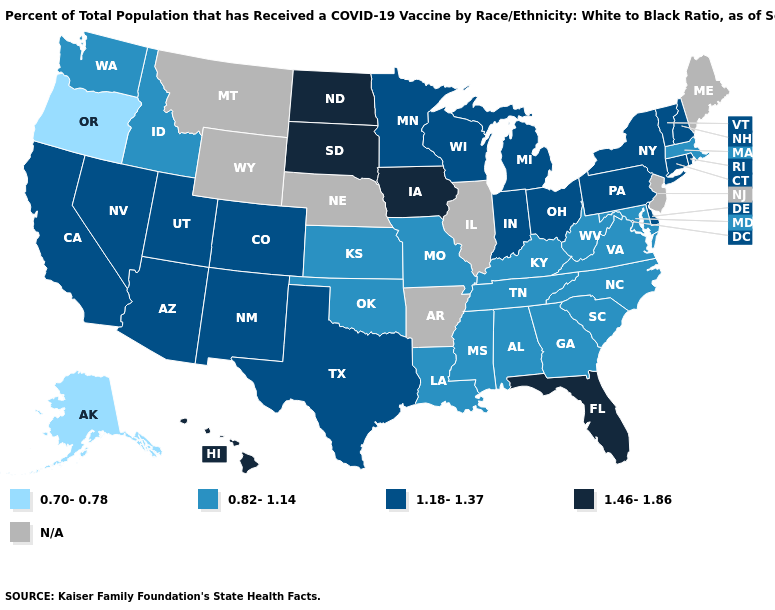What is the highest value in the Northeast ?
Answer briefly. 1.18-1.37. Does the first symbol in the legend represent the smallest category?
Short answer required. Yes. Is the legend a continuous bar?
Keep it brief. No. What is the lowest value in states that border North Dakota?
Give a very brief answer. 1.18-1.37. Does the first symbol in the legend represent the smallest category?
Write a very short answer. Yes. Which states hav the highest value in the West?
Be succinct. Hawaii. Does the map have missing data?
Concise answer only. Yes. What is the highest value in the USA?
Be succinct. 1.46-1.86. Which states hav the highest value in the MidWest?
Be succinct. Iowa, North Dakota, South Dakota. Name the states that have a value in the range 1.18-1.37?
Short answer required. Arizona, California, Colorado, Connecticut, Delaware, Indiana, Michigan, Minnesota, Nevada, New Hampshire, New Mexico, New York, Ohio, Pennsylvania, Rhode Island, Texas, Utah, Vermont, Wisconsin. What is the highest value in the USA?
Write a very short answer. 1.46-1.86. What is the highest value in states that border Arizona?
Concise answer only. 1.18-1.37. 